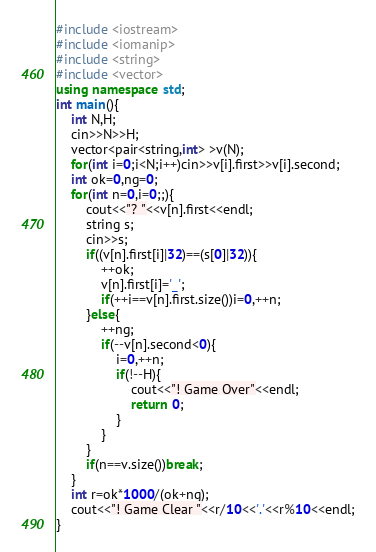Convert code to text. <code><loc_0><loc_0><loc_500><loc_500><_C++_>#include <iostream>
#include <iomanip>
#include <string>
#include <vector>
using namespace std;
int main(){
	int N,H;
	cin>>N>>H;
	vector<pair<string,int> >v(N);
	for(int i=0;i<N;i++)cin>>v[i].first>>v[i].second;
	int ok=0,ng=0;
	for(int n=0,i=0;;){
		cout<<"? "<<v[n].first<<endl;
		string s;
		cin>>s;
		if((v[n].first[i]|32)==(s[0]|32)){
			++ok;
			v[n].first[i]='_';
			if(++i==v[n].first.size())i=0,++n;
		}else{
			++ng;
			if(--v[n].second<0){
				i=0,++n;
				if(!--H){
					cout<<"! Game Over"<<endl;
					return 0;
				}
			}
		}
		if(n==v.size())break;
	}
	int r=ok*1000/(ok+ng);
	cout<<"! Game Clear "<<r/10<<'.'<<r%10<<endl;
}</code> 